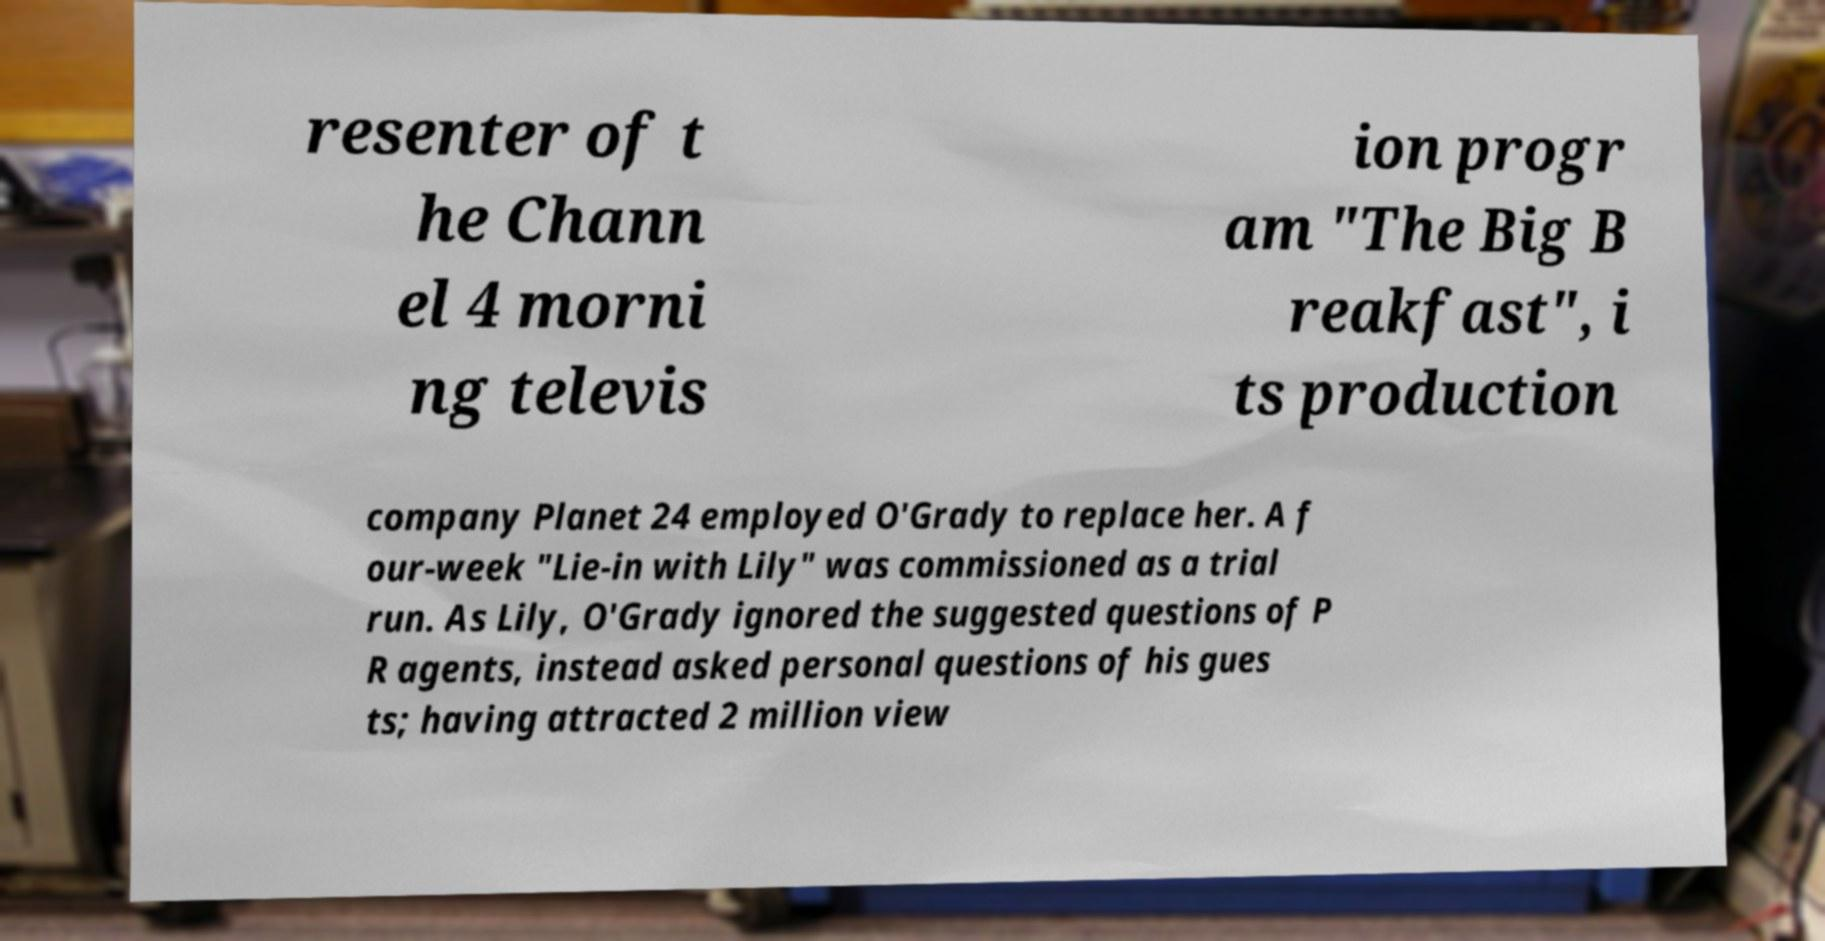What messages or text are displayed in this image? I need them in a readable, typed format. resenter of t he Chann el 4 morni ng televis ion progr am "The Big B reakfast", i ts production company Planet 24 employed O'Grady to replace her. A f our-week "Lie-in with Lily" was commissioned as a trial run. As Lily, O'Grady ignored the suggested questions of P R agents, instead asked personal questions of his gues ts; having attracted 2 million view 